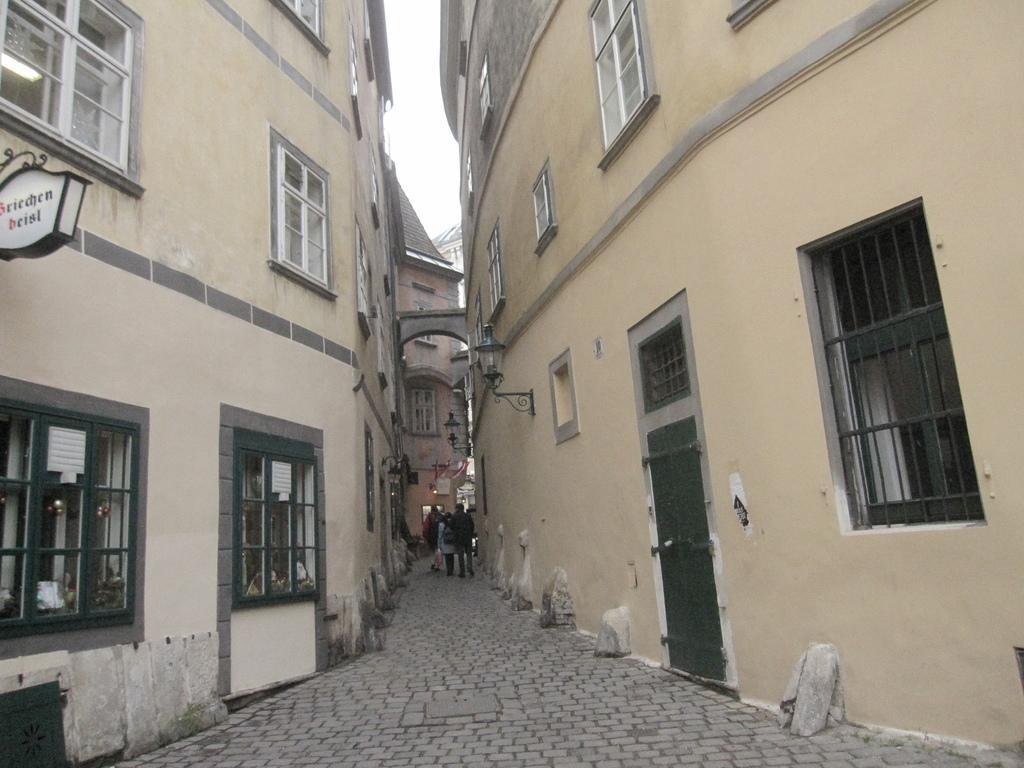Can you describe this image briefly? This picture shows few buildings and we see few people walking and we see a cloudy sky and a name board fixed to the wall and we see few Windows. 